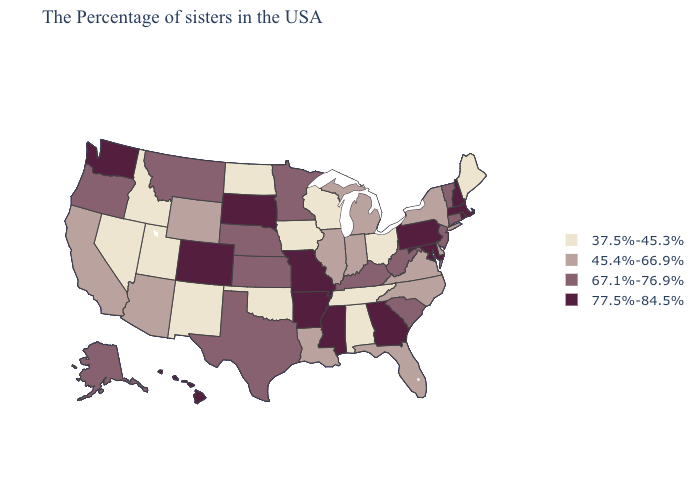Name the states that have a value in the range 67.1%-76.9%?
Short answer required. Vermont, Connecticut, New Jersey, South Carolina, West Virginia, Kentucky, Minnesota, Kansas, Nebraska, Texas, Montana, Oregon, Alaska. Name the states that have a value in the range 77.5%-84.5%?
Write a very short answer. Massachusetts, Rhode Island, New Hampshire, Maryland, Pennsylvania, Georgia, Mississippi, Missouri, Arkansas, South Dakota, Colorado, Washington, Hawaii. Among the states that border Indiana , which have the lowest value?
Give a very brief answer. Ohio. What is the highest value in the MidWest ?
Answer briefly. 77.5%-84.5%. What is the value of Montana?
Be succinct. 67.1%-76.9%. Does Maine have the lowest value in the USA?
Concise answer only. Yes. Does the first symbol in the legend represent the smallest category?
Keep it brief. Yes. What is the value of North Dakota?
Keep it brief. 37.5%-45.3%. What is the value of Florida?
Short answer required. 45.4%-66.9%. Does Montana have a lower value than Vermont?
Keep it brief. No. Does the map have missing data?
Keep it brief. No. Which states have the lowest value in the USA?
Be succinct. Maine, Ohio, Alabama, Tennessee, Wisconsin, Iowa, Oklahoma, North Dakota, New Mexico, Utah, Idaho, Nevada. Which states have the lowest value in the MidWest?
Give a very brief answer. Ohio, Wisconsin, Iowa, North Dakota. Name the states that have a value in the range 45.4%-66.9%?
Quick response, please. New York, Delaware, Virginia, North Carolina, Florida, Michigan, Indiana, Illinois, Louisiana, Wyoming, Arizona, California. What is the value of Pennsylvania?
Short answer required. 77.5%-84.5%. 